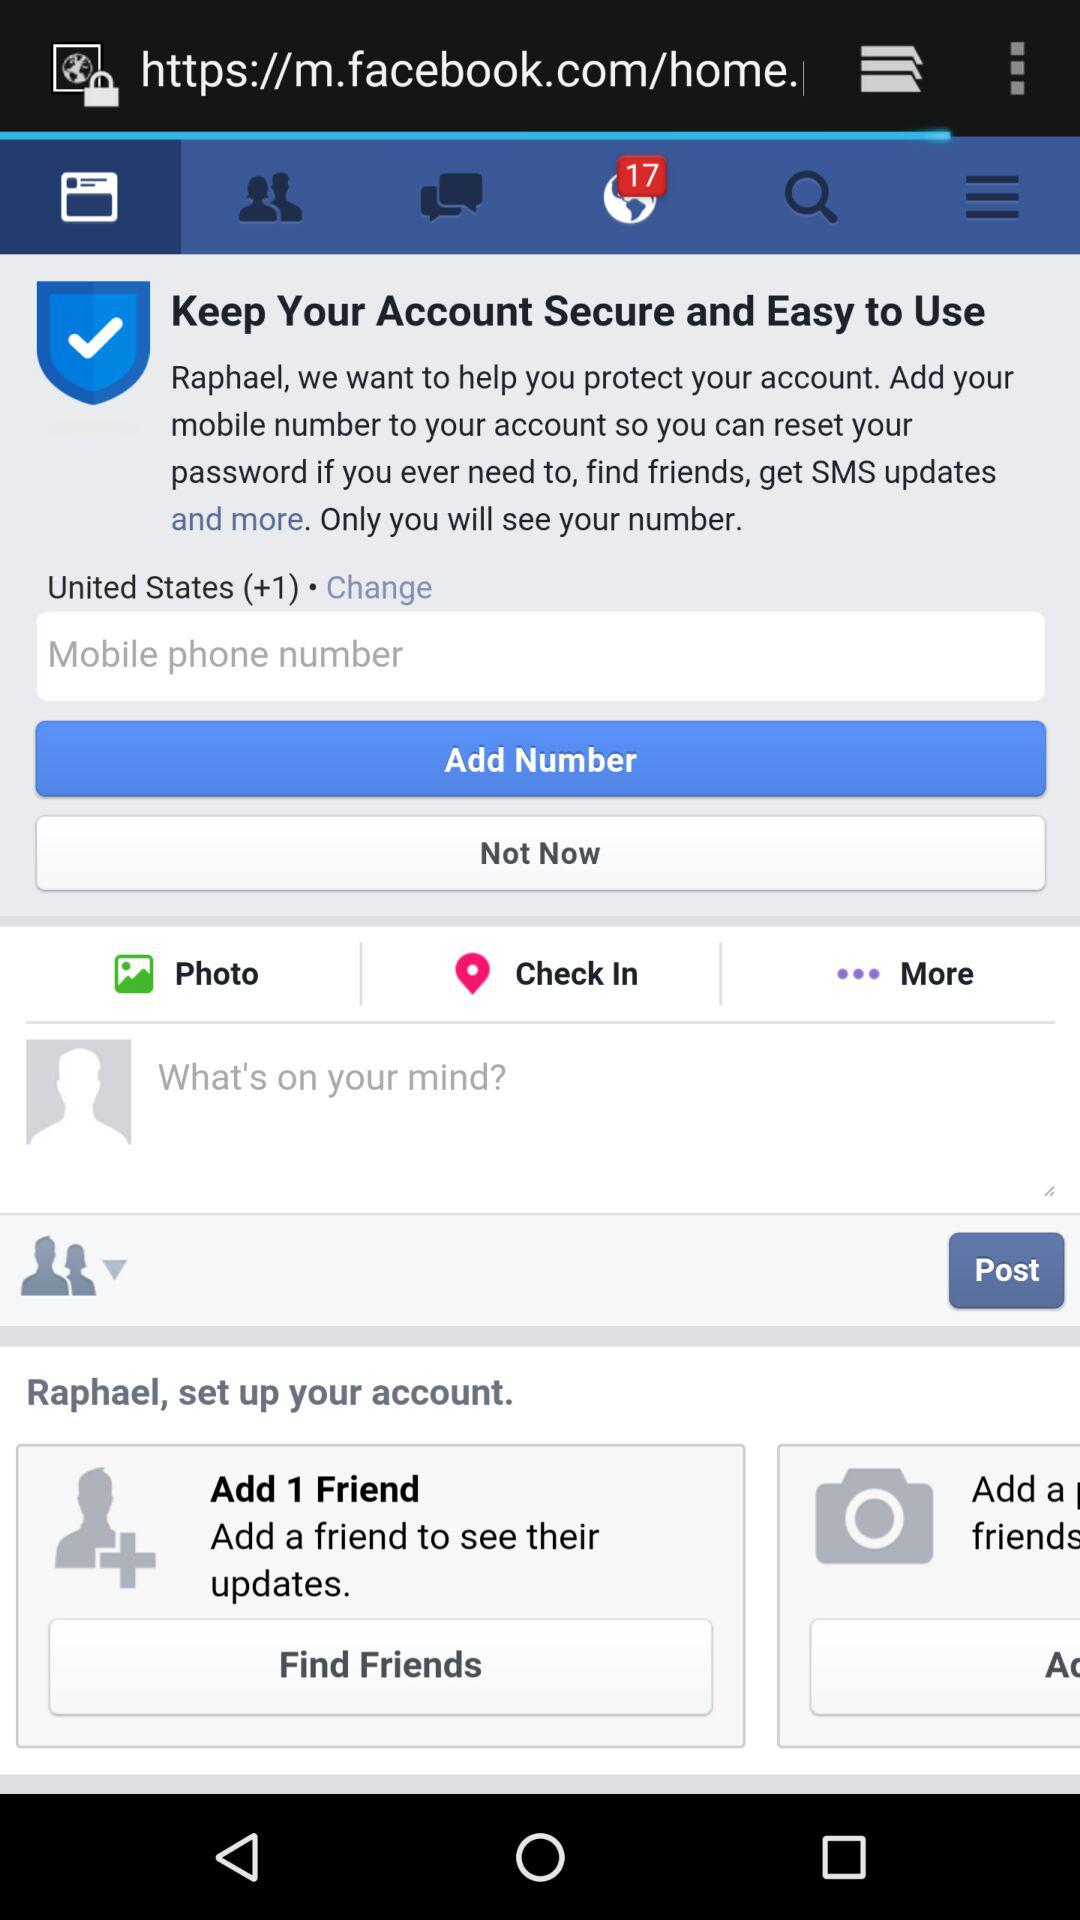What is the selected country? The selected country is the United States. 